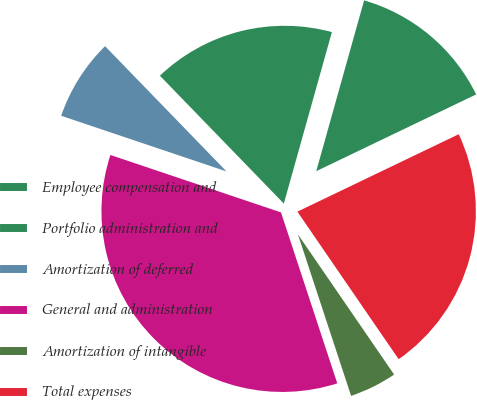Convert chart. <chart><loc_0><loc_0><loc_500><loc_500><pie_chart><fcel>Employee compensation and<fcel>Portfolio administration and<fcel>Amortization of deferred<fcel>General and administration<fcel>Amortization of intangible<fcel>Total expenses<nl><fcel>13.53%<fcel>16.6%<fcel>7.58%<fcel>35.23%<fcel>4.51%<fcel>22.55%<nl></chart> 